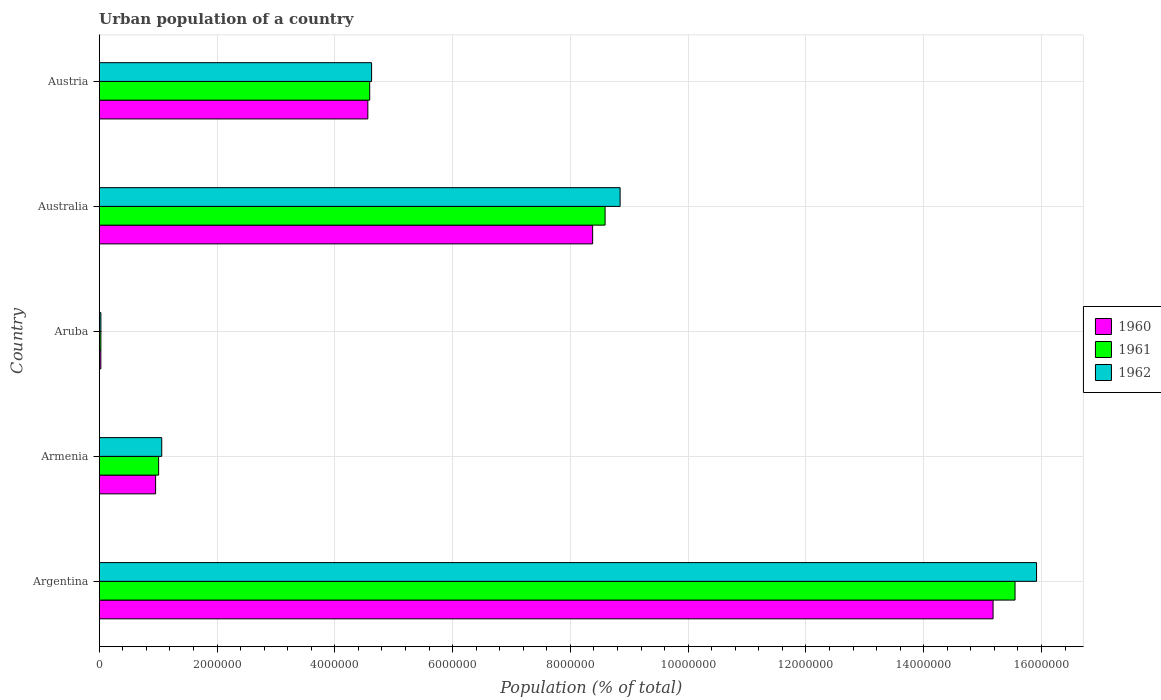How many bars are there on the 2nd tick from the bottom?
Provide a succinct answer. 3. What is the label of the 1st group of bars from the top?
Give a very brief answer. Austria. In how many cases, is the number of bars for a given country not equal to the number of legend labels?
Provide a short and direct response. 0. What is the urban population in 1961 in Armenia?
Ensure brevity in your answer.  1.01e+06. Across all countries, what is the maximum urban population in 1962?
Give a very brief answer. 1.59e+07. Across all countries, what is the minimum urban population in 1961?
Your response must be concise. 2.81e+04. In which country was the urban population in 1961 minimum?
Offer a very short reply. Aruba. What is the total urban population in 1960 in the graph?
Provide a short and direct response. 2.91e+07. What is the difference between the urban population in 1962 in Armenia and that in Aruba?
Provide a short and direct response. 1.03e+06. What is the difference between the urban population in 1960 in Aruba and the urban population in 1962 in Armenia?
Keep it short and to the point. -1.03e+06. What is the average urban population in 1961 per country?
Offer a very short reply. 5.95e+06. What is the difference between the urban population in 1960 and urban population in 1962 in Aruba?
Offer a terse response. -1007. In how many countries, is the urban population in 1961 greater than 3600000 %?
Offer a terse response. 3. What is the ratio of the urban population in 1960 in Armenia to that in Aruba?
Offer a very short reply. 34.79. What is the difference between the highest and the second highest urban population in 1962?
Provide a short and direct response. 7.07e+06. What is the difference between the highest and the lowest urban population in 1960?
Provide a short and direct response. 1.52e+07. In how many countries, is the urban population in 1960 greater than the average urban population in 1960 taken over all countries?
Ensure brevity in your answer.  2. What does the 2nd bar from the top in Armenia represents?
Your answer should be compact. 1961. How many bars are there?
Your answer should be very brief. 15. Are all the bars in the graph horizontal?
Your response must be concise. Yes. Does the graph contain any zero values?
Keep it short and to the point. No. Where does the legend appear in the graph?
Make the answer very short. Center right. How are the legend labels stacked?
Your answer should be compact. Vertical. What is the title of the graph?
Your response must be concise. Urban population of a country. What is the label or title of the X-axis?
Provide a succinct answer. Population (% of total). What is the Population (% of total) of 1960 in Argentina?
Your response must be concise. 1.52e+07. What is the Population (% of total) in 1961 in Argentina?
Make the answer very short. 1.56e+07. What is the Population (% of total) of 1962 in Argentina?
Make the answer very short. 1.59e+07. What is the Population (% of total) of 1960 in Armenia?
Keep it short and to the point. 9.58e+05. What is the Population (% of total) of 1961 in Armenia?
Your answer should be compact. 1.01e+06. What is the Population (% of total) of 1962 in Armenia?
Give a very brief answer. 1.06e+06. What is the Population (% of total) in 1960 in Aruba?
Make the answer very short. 2.75e+04. What is the Population (% of total) of 1961 in Aruba?
Give a very brief answer. 2.81e+04. What is the Population (% of total) of 1962 in Aruba?
Your answer should be compact. 2.85e+04. What is the Population (% of total) of 1960 in Australia?
Offer a very short reply. 8.38e+06. What is the Population (% of total) of 1961 in Australia?
Provide a succinct answer. 8.59e+06. What is the Population (% of total) in 1962 in Australia?
Your answer should be very brief. 8.84e+06. What is the Population (% of total) in 1960 in Austria?
Keep it short and to the point. 4.56e+06. What is the Population (% of total) of 1961 in Austria?
Your response must be concise. 4.59e+06. What is the Population (% of total) in 1962 in Austria?
Provide a short and direct response. 4.62e+06. Across all countries, what is the maximum Population (% of total) of 1960?
Provide a succinct answer. 1.52e+07. Across all countries, what is the maximum Population (% of total) in 1961?
Keep it short and to the point. 1.56e+07. Across all countries, what is the maximum Population (% of total) of 1962?
Your response must be concise. 1.59e+07. Across all countries, what is the minimum Population (% of total) of 1960?
Provide a succinct answer. 2.75e+04. Across all countries, what is the minimum Population (% of total) in 1961?
Your answer should be very brief. 2.81e+04. Across all countries, what is the minimum Population (% of total) of 1962?
Offer a terse response. 2.85e+04. What is the total Population (% of total) in 1960 in the graph?
Your response must be concise. 2.91e+07. What is the total Population (% of total) in 1961 in the graph?
Make the answer very short. 2.98e+07. What is the total Population (% of total) of 1962 in the graph?
Your response must be concise. 3.05e+07. What is the difference between the Population (% of total) of 1960 in Argentina and that in Armenia?
Offer a very short reply. 1.42e+07. What is the difference between the Population (% of total) of 1961 in Argentina and that in Armenia?
Provide a short and direct response. 1.45e+07. What is the difference between the Population (% of total) of 1962 in Argentina and that in Armenia?
Make the answer very short. 1.49e+07. What is the difference between the Population (% of total) of 1960 in Argentina and that in Aruba?
Provide a short and direct response. 1.52e+07. What is the difference between the Population (% of total) in 1961 in Argentina and that in Aruba?
Provide a succinct answer. 1.55e+07. What is the difference between the Population (% of total) of 1962 in Argentina and that in Aruba?
Offer a very short reply. 1.59e+07. What is the difference between the Population (% of total) in 1960 in Argentina and that in Australia?
Your answer should be compact. 6.80e+06. What is the difference between the Population (% of total) in 1961 in Argentina and that in Australia?
Keep it short and to the point. 6.96e+06. What is the difference between the Population (% of total) of 1962 in Argentina and that in Australia?
Your response must be concise. 7.07e+06. What is the difference between the Population (% of total) of 1960 in Argentina and that in Austria?
Give a very brief answer. 1.06e+07. What is the difference between the Population (% of total) of 1961 in Argentina and that in Austria?
Keep it short and to the point. 1.10e+07. What is the difference between the Population (% of total) in 1962 in Argentina and that in Austria?
Your answer should be compact. 1.13e+07. What is the difference between the Population (% of total) in 1960 in Armenia and that in Aruba?
Ensure brevity in your answer.  9.30e+05. What is the difference between the Population (% of total) in 1961 in Armenia and that in Aruba?
Provide a short and direct response. 9.81e+05. What is the difference between the Population (% of total) in 1962 in Armenia and that in Aruba?
Keep it short and to the point. 1.03e+06. What is the difference between the Population (% of total) of 1960 in Armenia and that in Australia?
Your response must be concise. -7.42e+06. What is the difference between the Population (% of total) in 1961 in Armenia and that in Australia?
Offer a terse response. -7.58e+06. What is the difference between the Population (% of total) in 1962 in Armenia and that in Australia?
Your answer should be compact. -7.78e+06. What is the difference between the Population (% of total) of 1960 in Armenia and that in Austria?
Your answer should be very brief. -3.60e+06. What is the difference between the Population (% of total) in 1961 in Armenia and that in Austria?
Your answer should be compact. -3.58e+06. What is the difference between the Population (% of total) in 1962 in Armenia and that in Austria?
Provide a succinct answer. -3.56e+06. What is the difference between the Population (% of total) of 1960 in Aruba and that in Australia?
Keep it short and to the point. -8.35e+06. What is the difference between the Population (% of total) in 1961 in Aruba and that in Australia?
Your answer should be compact. -8.56e+06. What is the difference between the Population (% of total) of 1962 in Aruba and that in Australia?
Your answer should be very brief. -8.82e+06. What is the difference between the Population (% of total) of 1960 in Aruba and that in Austria?
Make the answer very short. -4.53e+06. What is the difference between the Population (% of total) of 1961 in Aruba and that in Austria?
Give a very brief answer. -4.56e+06. What is the difference between the Population (% of total) of 1962 in Aruba and that in Austria?
Your response must be concise. -4.60e+06. What is the difference between the Population (% of total) in 1960 in Australia and that in Austria?
Make the answer very short. 3.82e+06. What is the difference between the Population (% of total) in 1961 in Australia and that in Austria?
Ensure brevity in your answer.  4.00e+06. What is the difference between the Population (% of total) in 1962 in Australia and that in Austria?
Provide a succinct answer. 4.22e+06. What is the difference between the Population (% of total) in 1960 in Argentina and the Population (% of total) in 1961 in Armenia?
Your response must be concise. 1.42e+07. What is the difference between the Population (% of total) in 1960 in Argentina and the Population (% of total) in 1962 in Armenia?
Offer a very short reply. 1.41e+07. What is the difference between the Population (% of total) of 1961 in Argentina and the Population (% of total) of 1962 in Armenia?
Keep it short and to the point. 1.45e+07. What is the difference between the Population (% of total) in 1960 in Argentina and the Population (% of total) in 1961 in Aruba?
Provide a succinct answer. 1.51e+07. What is the difference between the Population (% of total) of 1960 in Argentina and the Population (% of total) of 1962 in Aruba?
Provide a short and direct response. 1.51e+07. What is the difference between the Population (% of total) of 1961 in Argentina and the Population (% of total) of 1962 in Aruba?
Ensure brevity in your answer.  1.55e+07. What is the difference between the Population (% of total) in 1960 in Argentina and the Population (% of total) in 1961 in Australia?
Your answer should be compact. 6.59e+06. What is the difference between the Population (% of total) of 1960 in Argentina and the Population (% of total) of 1962 in Australia?
Your answer should be very brief. 6.33e+06. What is the difference between the Population (% of total) in 1961 in Argentina and the Population (% of total) in 1962 in Australia?
Provide a succinct answer. 6.71e+06. What is the difference between the Population (% of total) of 1960 in Argentina and the Population (% of total) of 1961 in Austria?
Ensure brevity in your answer.  1.06e+07. What is the difference between the Population (% of total) in 1960 in Argentina and the Population (% of total) in 1962 in Austria?
Offer a very short reply. 1.06e+07. What is the difference between the Population (% of total) of 1961 in Argentina and the Population (% of total) of 1962 in Austria?
Provide a short and direct response. 1.09e+07. What is the difference between the Population (% of total) in 1960 in Armenia and the Population (% of total) in 1961 in Aruba?
Your answer should be very brief. 9.29e+05. What is the difference between the Population (% of total) in 1960 in Armenia and the Population (% of total) in 1962 in Aruba?
Give a very brief answer. 9.29e+05. What is the difference between the Population (% of total) of 1961 in Armenia and the Population (% of total) of 1962 in Aruba?
Give a very brief answer. 9.80e+05. What is the difference between the Population (% of total) in 1960 in Armenia and the Population (% of total) in 1961 in Australia?
Provide a short and direct response. -7.63e+06. What is the difference between the Population (% of total) of 1960 in Armenia and the Population (% of total) of 1962 in Australia?
Keep it short and to the point. -7.89e+06. What is the difference between the Population (% of total) of 1961 in Armenia and the Population (% of total) of 1962 in Australia?
Offer a very short reply. -7.84e+06. What is the difference between the Population (% of total) of 1960 in Armenia and the Population (% of total) of 1961 in Austria?
Make the answer very short. -3.64e+06. What is the difference between the Population (% of total) in 1960 in Armenia and the Population (% of total) in 1962 in Austria?
Ensure brevity in your answer.  -3.67e+06. What is the difference between the Population (% of total) of 1961 in Armenia and the Population (% of total) of 1962 in Austria?
Ensure brevity in your answer.  -3.62e+06. What is the difference between the Population (% of total) of 1960 in Aruba and the Population (% of total) of 1961 in Australia?
Your answer should be compact. -8.56e+06. What is the difference between the Population (% of total) of 1960 in Aruba and the Population (% of total) of 1962 in Australia?
Give a very brief answer. -8.82e+06. What is the difference between the Population (% of total) in 1961 in Aruba and the Population (% of total) in 1962 in Australia?
Ensure brevity in your answer.  -8.82e+06. What is the difference between the Population (% of total) of 1960 in Aruba and the Population (% of total) of 1961 in Austria?
Keep it short and to the point. -4.57e+06. What is the difference between the Population (% of total) in 1960 in Aruba and the Population (% of total) in 1962 in Austria?
Your response must be concise. -4.60e+06. What is the difference between the Population (% of total) of 1961 in Aruba and the Population (% of total) of 1962 in Austria?
Your response must be concise. -4.60e+06. What is the difference between the Population (% of total) in 1960 in Australia and the Population (% of total) in 1961 in Austria?
Ensure brevity in your answer.  3.79e+06. What is the difference between the Population (% of total) of 1960 in Australia and the Population (% of total) of 1962 in Austria?
Your answer should be very brief. 3.75e+06. What is the difference between the Population (% of total) of 1961 in Australia and the Population (% of total) of 1962 in Austria?
Keep it short and to the point. 3.97e+06. What is the average Population (% of total) in 1960 per country?
Provide a succinct answer. 5.82e+06. What is the average Population (% of total) in 1961 per country?
Offer a terse response. 5.95e+06. What is the average Population (% of total) in 1962 per country?
Offer a terse response. 6.10e+06. What is the difference between the Population (% of total) of 1960 and Population (% of total) of 1961 in Argentina?
Give a very brief answer. -3.73e+05. What is the difference between the Population (% of total) of 1960 and Population (% of total) of 1962 in Argentina?
Your answer should be compact. -7.38e+05. What is the difference between the Population (% of total) of 1961 and Population (% of total) of 1962 in Argentina?
Offer a very short reply. -3.65e+05. What is the difference between the Population (% of total) in 1960 and Population (% of total) in 1961 in Armenia?
Ensure brevity in your answer.  -5.11e+04. What is the difference between the Population (% of total) in 1960 and Population (% of total) in 1962 in Armenia?
Your answer should be compact. -1.04e+05. What is the difference between the Population (% of total) in 1961 and Population (% of total) in 1962 in Armenia?
Provide a short and direct response. -5.29e+04. What is the difference between the Population (% of total) in 1960 and Population (% of total) in 1961 in Aruba?
Offer a very short reply. -614. What is the difference between the Population (% of total) of 1960 and Population (% of total) of 1962 in Aruba?
Provide a succinct answer. -1007. What is the difference between the Population (% of total) in 1961 and Population (% of total) in 1962 in Aruba?
Give a very brief answer. -393. What is the difference between the Population (% of total) in 1960 and Population (% of total) in 1961 in Australia?
Offer a terse response. -2.12e+05. What is the difference between the Population (% of total) in 1960 and Population (% of total) in 1962 in Australia?
Offer a very short reply. -4.66e+05. What is the difference between the Population (% of total) of 1961 and Population (% of total) of 1962 in Australia?
Your response must be concise. -2.55e+05. What is the difference between the Population (% of total) of 1960 and Population (% of total) of 1961 in Austria?
Provide a short and direct response. -3.17e+04. What is the difference between the Population (% of total) in 1960 and Population (% of total) in 1962 in Austria?
Provide a succinct answer. -6.35e+04. What is the difference between the Population (% of total) in 1961 and Population (% of total) in 1962 in Austria?
Your response must be concise. -3.17e+04. What is the ratio of the Population (% of total) in 1960 in Argentina to that in Armenia?
Ensure brevity in your answer.  15.85. What is the ratio of the Population (% of total) of 1961 in Argentina to that in Armenia?
Your response must be concise. 15.42. What is the ratio of the Population (% of total) of 1962 in Argentina to that in Armenia?
Keep it short and to the point. 14.99. What is the ratio of the Population (% of total) in 1960 in Argentina to that in Aruba?
Ensure brevity in your answer.  551.42. What is the ratio of the Population (% of total) of 1961 in Argentina to that in Aruba?
Your answer should be very brief. 552.64. What is the ratio of the Population (% of total) of 1962 in Argentina to that in Aruba?
Your response must be concise. 557.84. What is the ratio of the Population (% of total) of 1960 in Argentina to that in Australia?
Provide a short and direct response. 1.81. What is the ratio of the Population (% of total) of 1961 in Argentina to that in Australia?
Provide a succinct answer. 1.81. What is the ratio of the Population (% of total) in 1962 in Argentina to that in Australia?
Offer a very short reply. 1.8. What is the ratio of the Population (% of total) of 1960 in Argentina to that in Austria?
Your response must be concise. 3.33. What is the ratio of the Population (% of total) of 1961 in Argentina to that in Austria?
Give a very brief answer. 3.39. What is the ratio of the Population (% of total) of 1962 in Argentina to that in Austria?
Provide a succinct answer. 3.44. What is the ratio of the Population (% of total) of 1960 in Armenia to that in Aruba?
Your answer should be very brief. 34.79. What is the ratio of the Population (% of total) of 1961 in Armenia to that in Aruba?
Provide a short and direct response. 35.85. What is the ratio of the Population (% of total) in 1962 in Armenia to that in Aruba?
Keep it short and to the point. 37.2. What is the ratio of the Population (% of total) of 1960 in Armenia to that in Australia?
Offer a terse response. 0.11. What is the ratio of the Population (% of total) of 1961 in Armenia to that in Australia?
Offer a very short reply. 0.12. What is the ratio of the Population (% of total) of 1962 in Armenia to that in Australia?
Your response must be concise. 0.12. What is the ratio of the Population (% of total) in 1960 in Armenia to that in Austria?
Offer a very short reply. 0.21. What is the ratio of the Population (% of total) of 1961 in Armenia to that in Austria?
Your answer should be compact. 0.22. What is the ratio of the Population (% of total) of 1962 in Armenia to that in Austria?
Provide a short and direct response. 0.23. What is the ratio of the Population (% of total) in 1960 in Aruba to that in Australia?
Your answer should be compact. 0. What is the ratio of the Population (% of total) in 1961 in Aruba to that in Australia?
Keep it short and to the point. 0. What is the ratio of the Population (% of total) in 1962 in Aruba to that in Australia?
Your answer should be compact. 0. What is the ratio of the Population (% of total) in 1960 in Aruba to that in Austria?
Your answer should be compact. 0.01. What is the ratio of the Population (% of total) in 1961 in Aruba to that in Austria?
Give a very brief answer. 0.01. What is the ratio of the Population (% of total) of 1962 in Aruba to that in Austria?
Offer a very short reply. 0.01. What is the ratio of the Population (% of total) in 1960 in Australia to that in Austria?
Make the answer very short. 1.84. What is the ratio of the Population (% of total) of 1961 in Australia to that in Austria?
Your response must be concise. 1.87. What is the ratio of the Population (% of total) of 1962 in Australia to that in Austria?
Your answer should be compact. 1.91. What is the difference between the highest and the second highest Population (% of total) of 1960?
Your answer should be compact. 6.80e+06. What is the difference between the highest and the second highest Population (% of total) in 1961?
Give a very brief answer. 6.96e+06. What is the difference between the highest and the second highest Population (% of total) of 1962?
Ensure brevity in your answer.  7.07e+06. What is the difference between the highest and the lowest Population (% of total) of 1960?
Keep it short and to the point. 1.52e+07. What is the difference between the highest and the lowest Population (% of total) in 1961?
Your response must be concise. 1.55e+07. What is the difference between the highest and the lowest Population (% of total) in 1962?
Provide a short and direct response. 1.59e+07. 